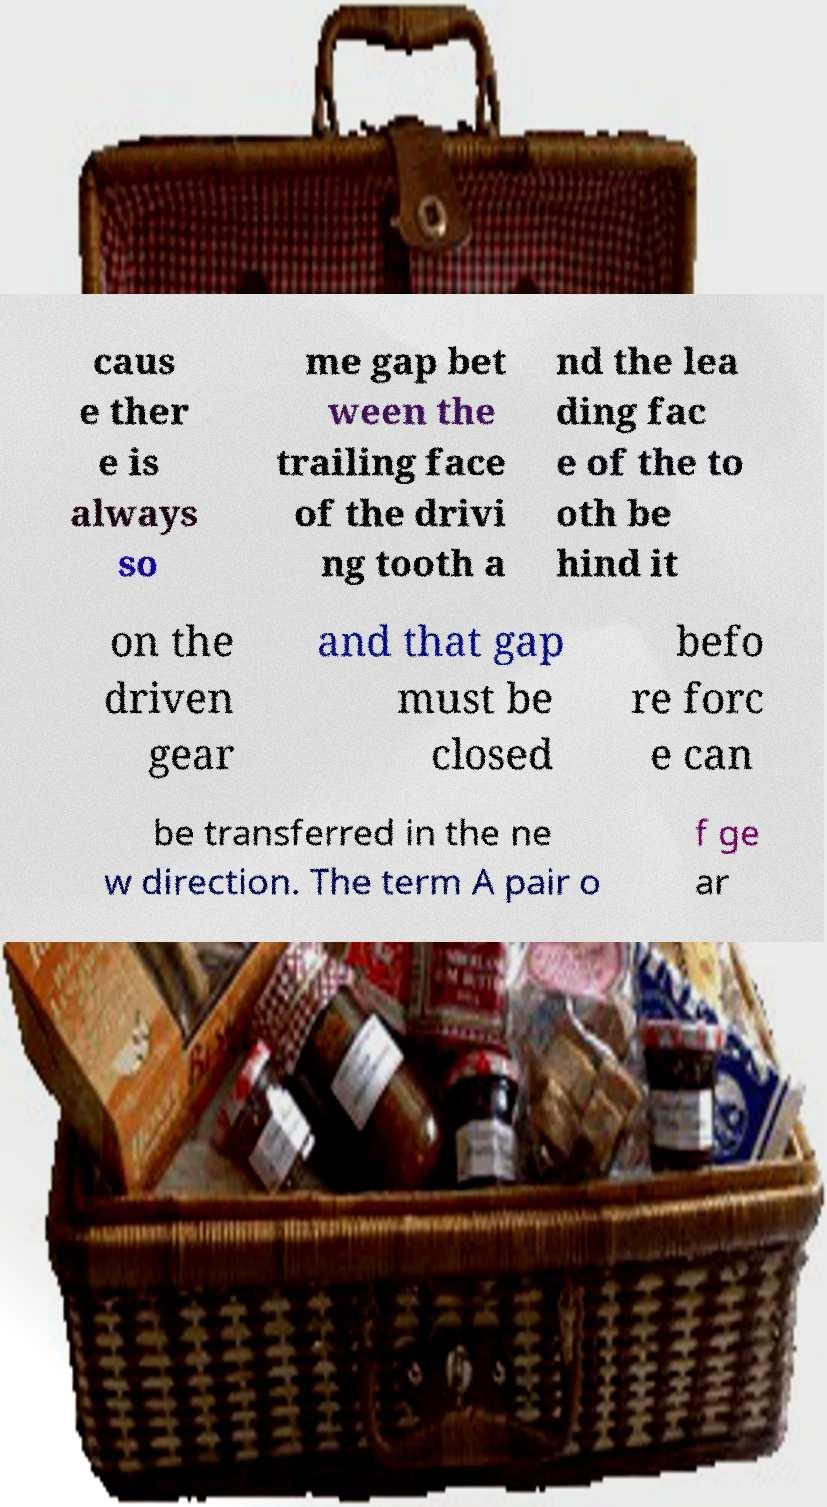Could you assist in decoding the text presented in this image and type it out clearly? caus e ther e is always so me gap bet ween the trailing face of the drivi ng tooth a nd the lea ding fac e of the to oth be hind it on the driven gear and that gap must be closed befo re forc e can be transferred in the ne w direction. The term A pair o f ge ar 